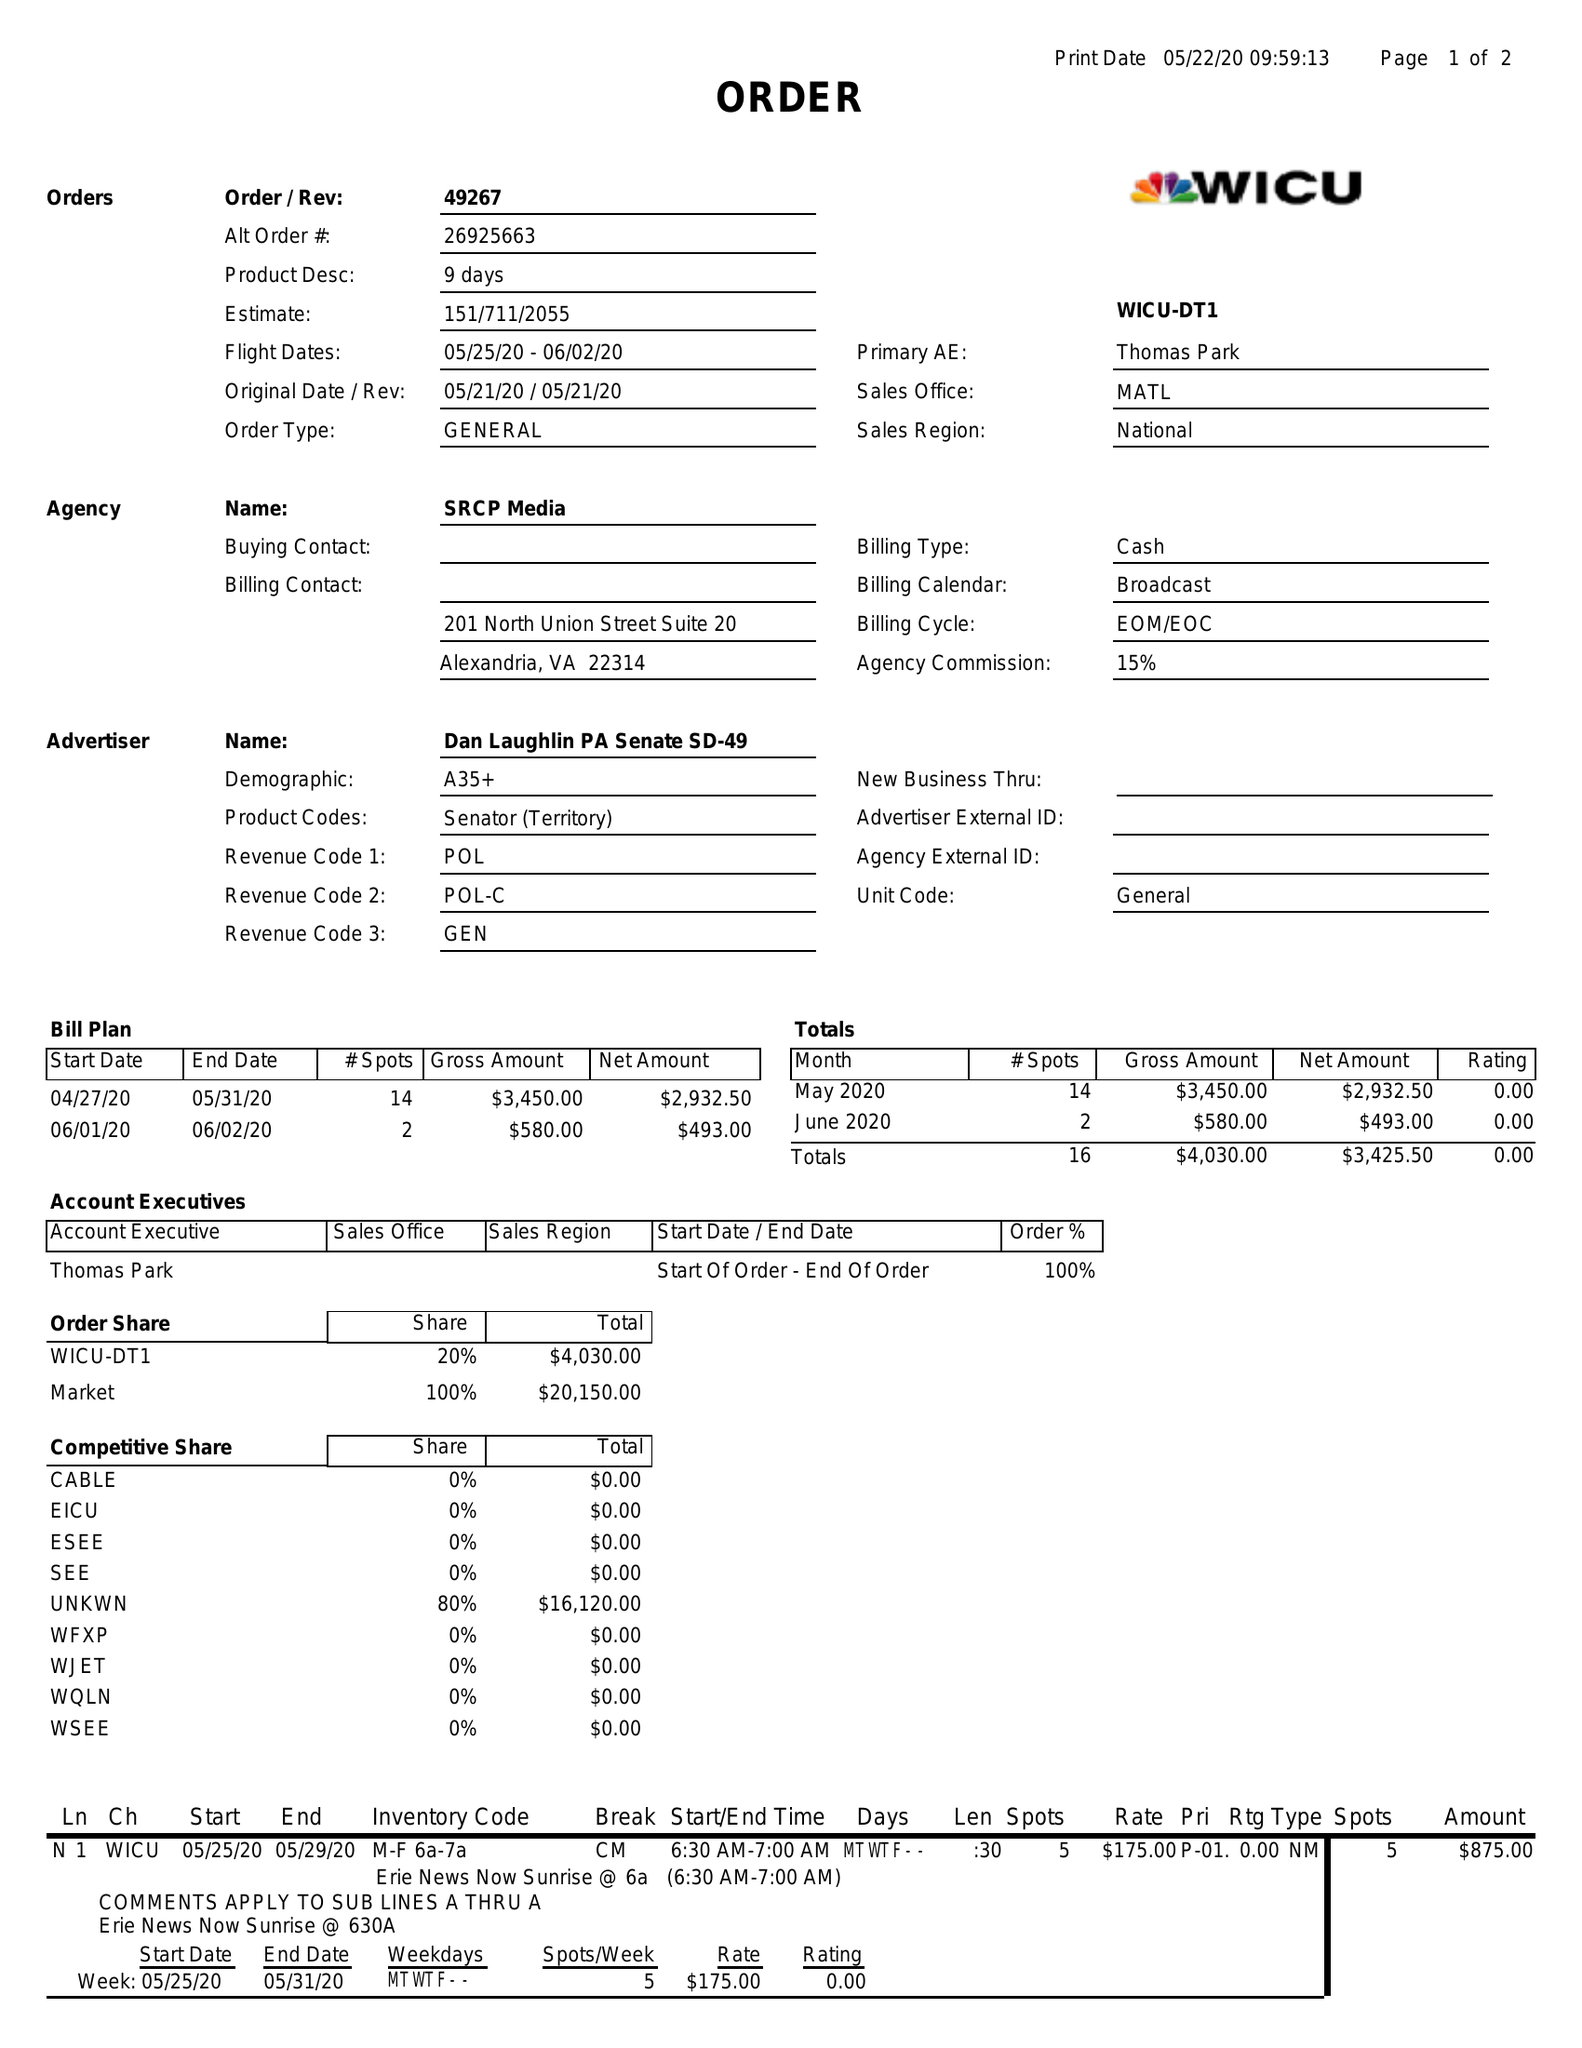What is the value for the gross_amount?
Answer the question using a single word or phrase. 4030.00 